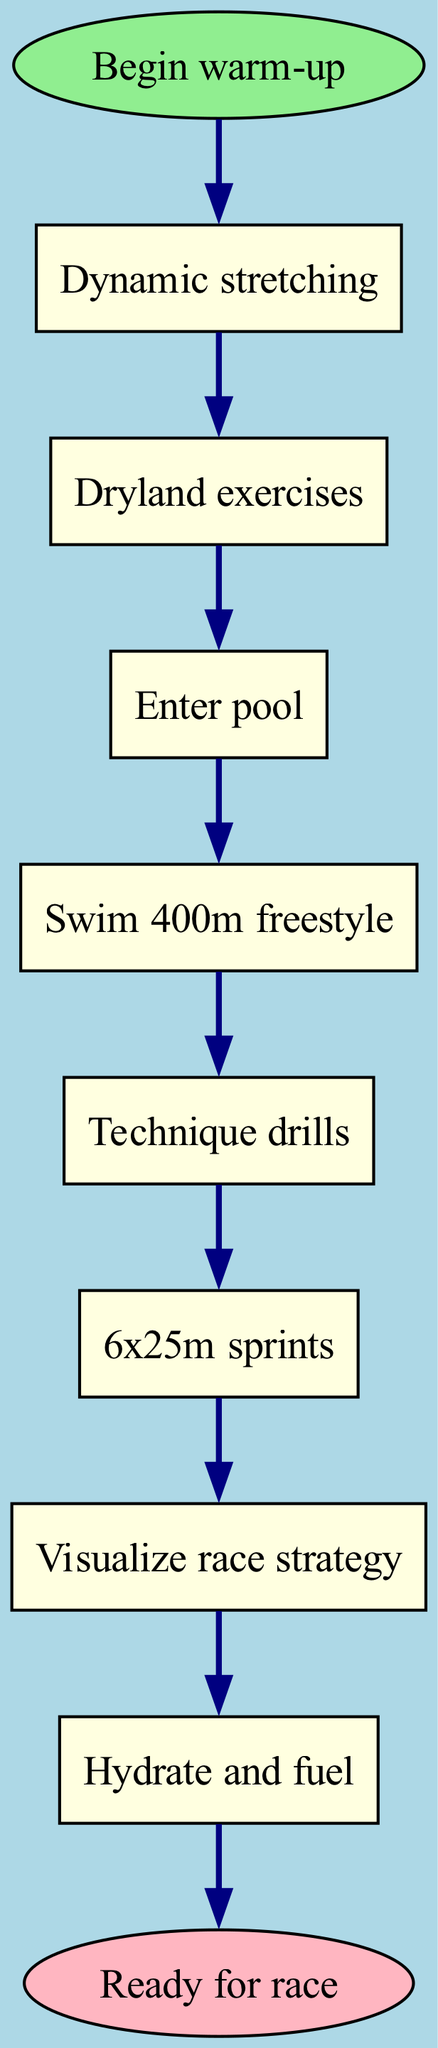What is the first step in the warm-up routine? The diagram starts at the "Begin warm-up" node, which leads to the first step, "Dynamic stretching".
Answer: Dynamic stretching How many nodes are in the diagram? The diagram consists of 8 nodes including the start and end nodes. Counting all nodes gives "Begin warm-up", "Dynamic stretching", "Dryland exercises", "Enter pool", "Swim 400m freestyle", "Technique drills", "6x25m sprints", and "Visualize race strategy".
Answer: 8 What is the last activity before hydrating? The flow chart shows that after "Visualize race strategy", the last activity is "Hydrate and fuel".
Answer: Hydrate and fuel Which node follows the "Technique drills"? According to the diagram, the node that follows "Technique drills" is "6x25m sprints". This indicates the order of activities in the warm-up routine.
Answer: 6x25m sprints What color is the node for "Dryland exercises"? The node for "Dryland exercises" is filled with light yellow, as indicated in the diagram's design for intermediate nodes.
Answer: Light yellow What is the relationship between "Swim 400m freestyle" and "Technique drills"? In the diagram, "Swim 400m freestyle" directly leads to "Technique drills", indicating a sequential flow of the warm-up routine from swimming to practicing techniques.
Answer: Sequential flow What is the final step in the routine? The diagram concludes with "Ready for race" after "Hydrate and fuel", which signifies the end of the warm-up routine before competing.
Answer: Ready for race How many exercises are done before entering the pool? According to the flow, only "Dynamic stretching" and "Dryland exercises" are performed before the "Enter pool" node.
Answer: 2 